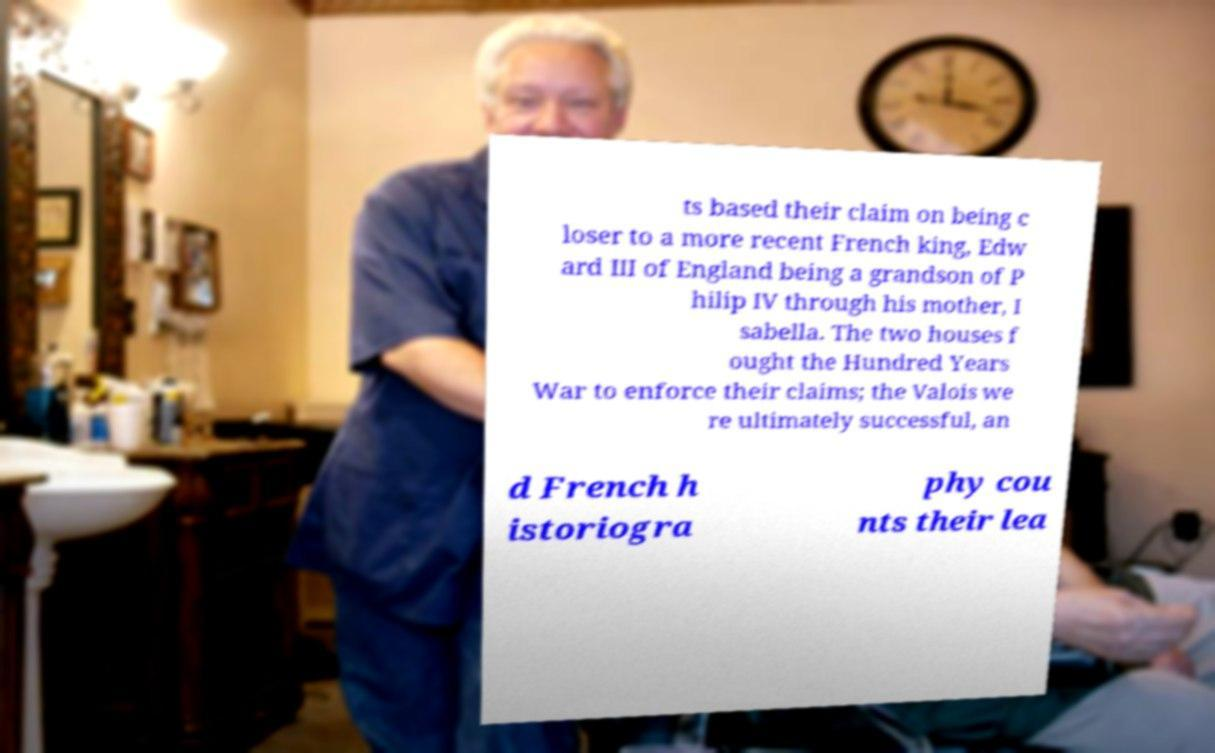Could you extract and type out the text from this image? ts based their claim on being c loser to a more recent French king, Edw ard III of England being a grandson of P hilip IV through his mother, I sabella. The two houses f ought the Hundred Years War to enforce their claims; the Valois we re ultimately successful, an d French h istoriogra phy cou nts their lea 